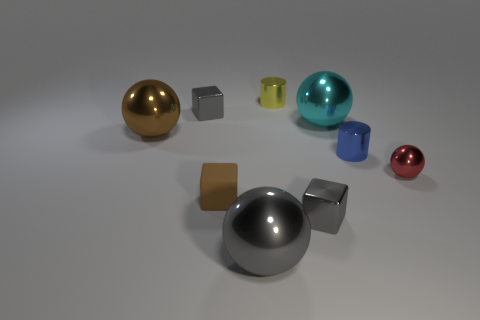Are there any other things that have the same material as the brown block?
Make the answer very short. No. There is a small blue object; what shape is it?
Ensure brevity in your answer.  Cylinder. What shape is the gray shiny object behind the gray object to the right of the gray metal ball?
Give a very brief answer. Cube. What number of other objects are the same shape as the matte object?
Your answer should be compact. 2. There is a gray metallic thing that is on the right side of the metal sphere that is in front of the tiny brown rubber object; what size is it?
Provide a short and direct response. Small. Are any small metal cylinders visible?
Offer a very short reply. Yes. There is a big shiny thing that is in front of the small rubber cube; how many small gray metallic blocks are on the left side of it?
Offer a terse response. 1. There is a large object that is on the right side of the small yellow shiny cylinder; what shape is it?
Make the answer very short. Sphere. What is the material of the object on the left side of the small gray cube left of the gray cube in front of the small red metallic ball?
Your answer should be very brief. Metal. What number of other things are the same size as the brown cube?
Keep it short and to the point. 5. 